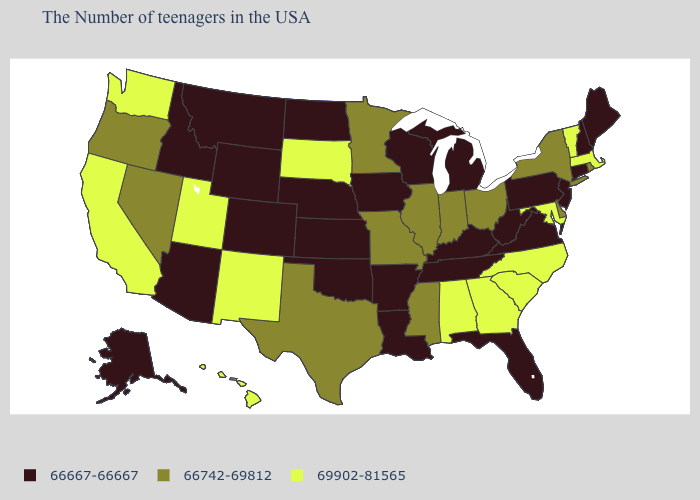Name the states that have a value in the range 66742-69812?
Answer briefly. Rhode Island, New York, Delaware, Ohio, Indiana, Illinois, Mississippi, Missouri, Minnesota, Texas, Nevada, Oregon. What is the value of Rhode Island?
Write a very short answer. 66742-69812. Which states have the highest value in the USA?
Keep it brief. Massachusetts, Vermont, Maryland, North Carolina, South Carolina, Georgia, Alabama, South Dakota, New Mexico, Utah, California, Washington, Hawaii. What is the value of New Mexico?
Quick response, please. 69902-81565. Among the states that border Washington , which have the highest value?
Short answer required. Oregon. What is the value of Washington?
Short answer required. 69902-81565. Which states hav the highest value in the Northeast?
Quick response, please. Massachusetts, Vermont. What is the value of Illinois?
Quick response, please. 66742-69812. Name the states that have a value in the range 66742-69812?
Short answer required. Rhode Island, New York, Delaware, Ohio, Indiana, Illinois, Mississippi, Missouri, Minnesota, Texas, Nevada, Oregon. What is the value of Iowa?
Answer briefly. 66667-66667. Name the states that have a value in the range 66667-66667?
Answer briefly. Maine, New Hampshire, Connecticut, New Jersey, Pennsylvania, Virginia, West Virginia, Florida, Michigan, Kentucky, Tennessee, Wisconsin, Louisiana, Arkansas, Iowa, Kansas, Nebraska, Oklahoma, North Dakota, Wyoming, Colorado, Montana, Arizona, Idaho, Alaska. Name the states that have a value in the range 69902-81565?
Write a very short answer. Massachusetts, Vermont, Maryland, North Carolina, South Carolina, Georgia, Alabama, South Dakota, New Mexico, Utah, California, Washington, Hawaii. Does Arizona have the highest value in the USA?
Write a very short answer. No. Does Connecticut have the highest value in the Northeast?
Concise answer only. No. Name the states that have a value in the range 66742-69812?
Quick response, please. Rhode Island, New York, Delaware, Ohio, Indiana, Illinois, Mississippi, Missouri, Minnesota, Texas, Nevada, Oregon. 